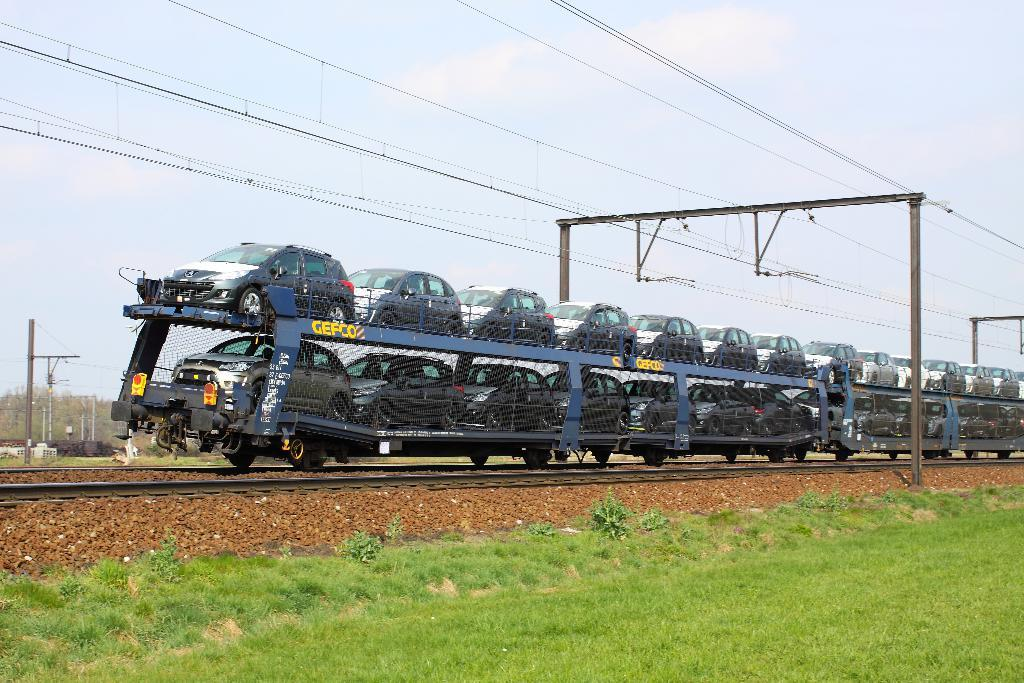What type of vehicles are in the train in the image? There are cars in a train in the image. What can be seen at the top of the image? Electric cables are visible at the top of the image. What type of vegetation is present in the image? There is grass visible in the image. How many snakes are slithering through the grass in the image? There are no snakes present in the image; it only shows a train with cars, electric cables, and grass. What position is the train in the image? The position of the train cannot be determined from the image alone, as it only shows a portion of the train. 